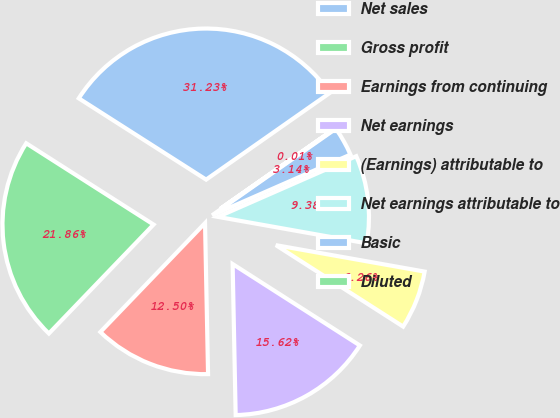<chart> <loc_0><loc_0><loc_500><loc_500><pie_chart><fcel>Net sales<fcel>Gross profit<fcel>Earnings from continuing<fcel>Net earnings<fcel>(Earnings) attributable to<fcel>Net earnings attributable to<fcel>Basic<fcel>Diluted<nl><fcel>31.23%<fcel>21.86%<fcel>12.5%<fcel>15.62%<fcel>6.26%<fcel>9.38%<fcel>3.14%<fcel>0.01%<nl></chart> 